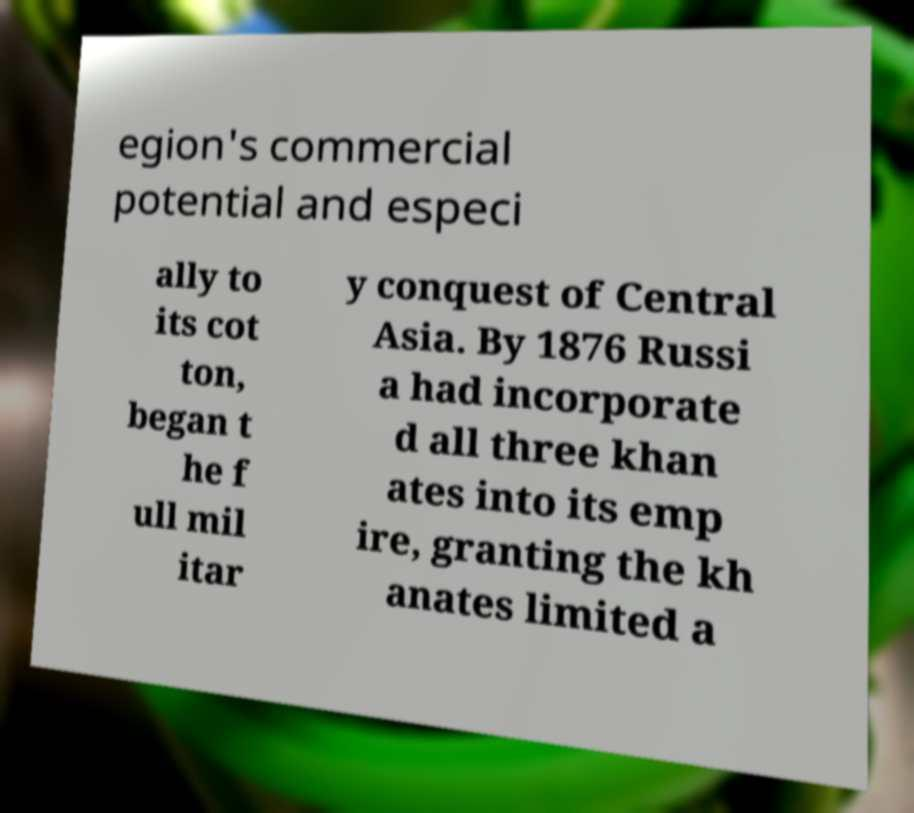Could you extract and type out the text from this image? egion's commercial potential and especi ally to its cot ton, began t he f ull mil itar y conquest of Central Asia. By 1876 Russi a had incorporate d all three khan ates into its emp ire, granting the kh anates limited a 